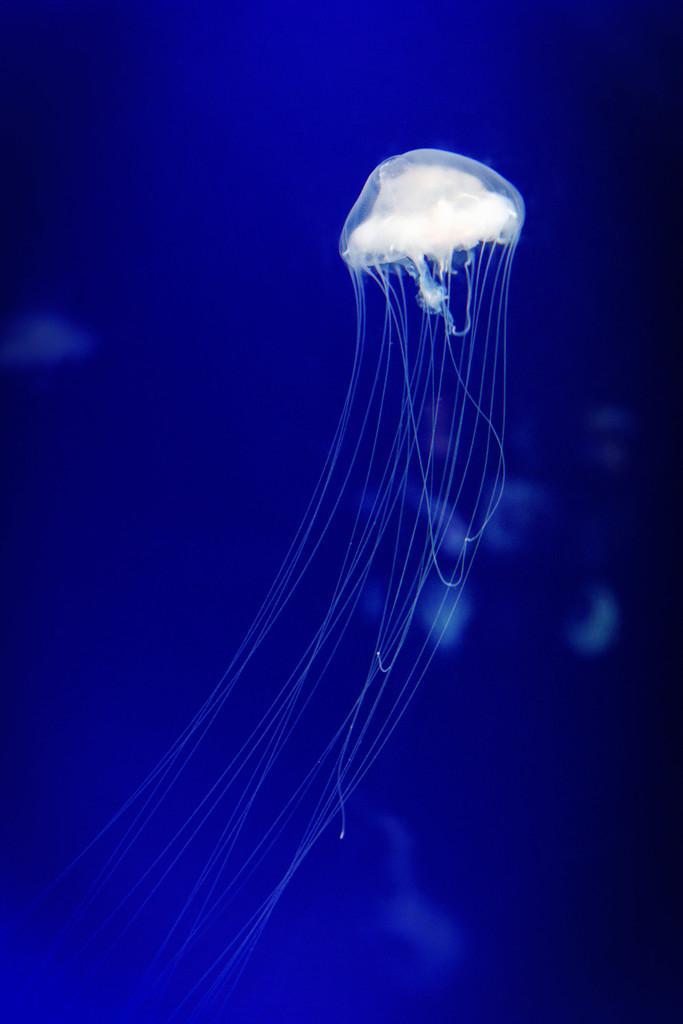Please provide a concise description of this image. In this image I can see a white colour jellyfish in the front and I can also see blue colour in the background. I can also see few white colour things in the background. 